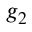<formula> <loc_0><loc_0><loc_500><loc_500>g _ { 2 }</formula> 